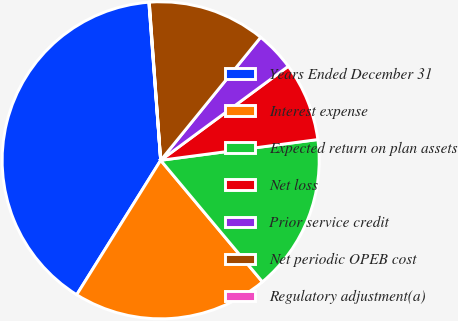<chart> <loc_0><loc_0><loc_500><loc_500><pie_chart><fcel>Years Ended December 31<fcel>Interest expense<fcel>Expected return on plan assets<fcel>Net loss<fcel>Prior service credit<fcel>Net periodic OPEB cost<fcel>Regulatory adjustment(a)<nl><fcel>39.93%<fcel>19.98%<fcel>16.0%<fcel>8.02%<fcel>4.03%<fcel>12.01%<fcel>0.04%<nl></chart> 